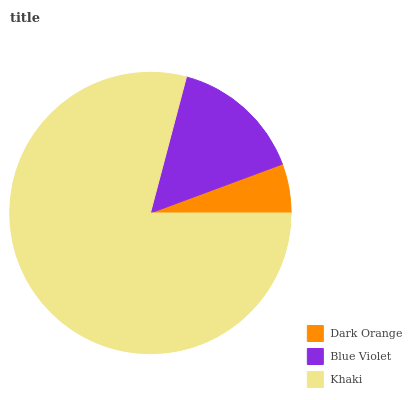Is Dark Orange the minimum?
Answer yes or no. Yes. Is Khaki the maximum?
Answer yes or no. Yes. Is Blue Violet the minimum?
Answer yes or no. No. Is Blue Violet the maximum?
Answer yes or no. No. Is Blue Violet greater than Dark Orange?
Answer yes or no. Yes. Is Dark Orange less than Blue Violet?
Answer yes or no. Yes. Is Dark Orange greater than Blue Violet?
Answer yes or no. No. Is Blue Violet less than Dark Orange?
Answer yes or no. No. Is Blue Violet the high median?
Answer yes or no. Yes. Is Blue Violet the low median?
Answer yes or no. Yes. Is Dark Orange the high median?
Answer yes or no. No. Is Dark Orange the low median?
Answer yes or no. No. 